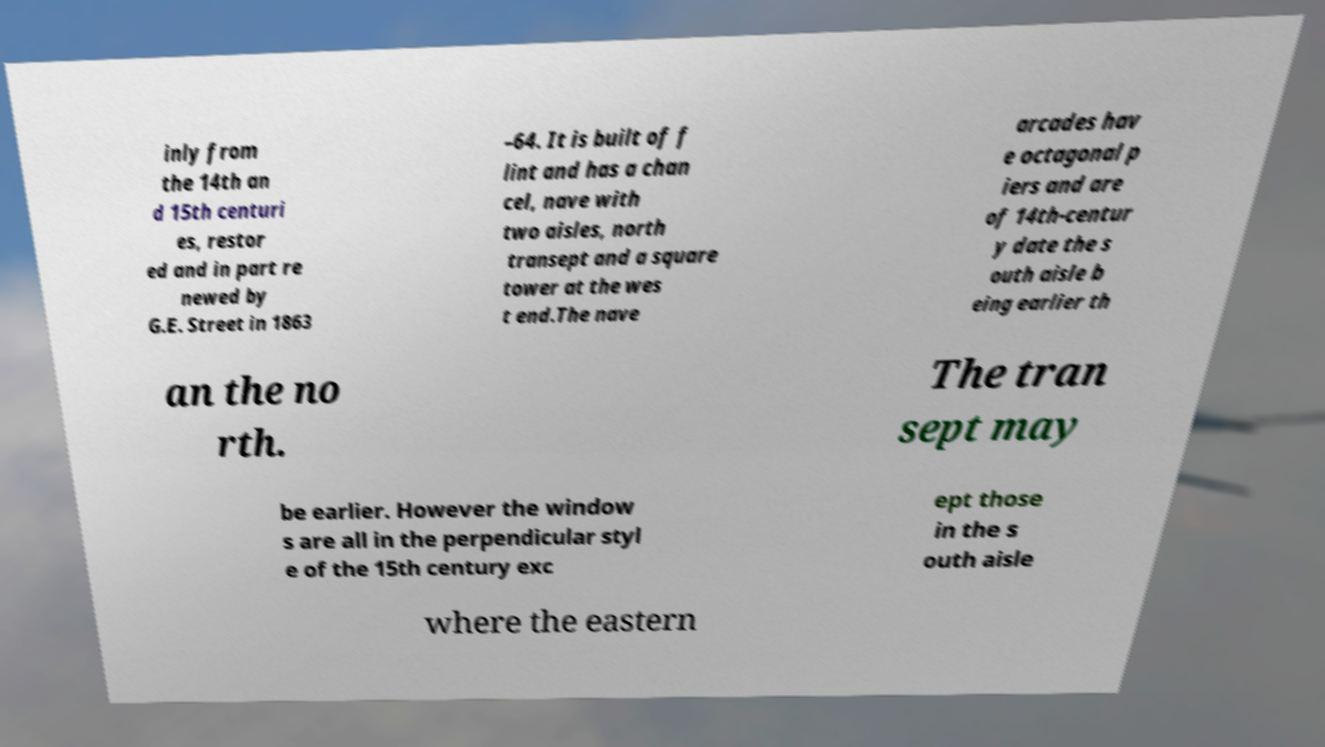Could you assist in decoding the text presented in this image and type it out clearly? inly from the 14th an d 15th centuri es, restor ed and in part re newed by G.E. Street in 1863 –64. It is built of f lint and has a chan cel, nave with two aisles, north transept and a square tower at the wes t end.The nave arcades hav e octagonal p iers and are of 14th-centur y date the s outh aisle b eing earlier th an the no rth. The tran sept may be earlier. However the window s are all in the perpendicular styl e of the 15th century exc ept those in the s outh aisle where the eastern 